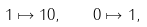<formula> <loc_0><loc_0><loc_500><loc_500>1 \mapsto 1 0 , \quad 0 \mapsto 1 ,</formula> 